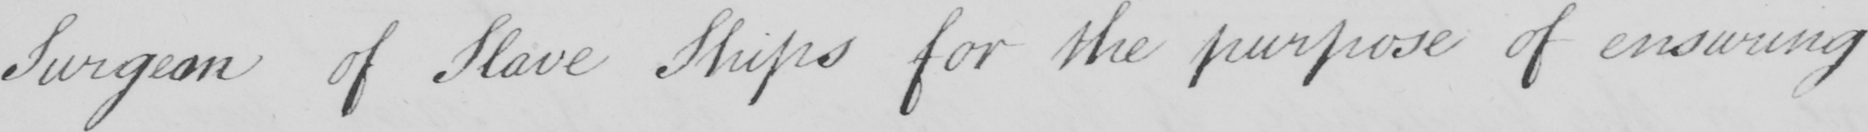Can you tell me what this handwritten text says? Surgeon of Slave Ships for the purpose of ensuring 